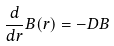Convert formula to latex. <formula><loc_0><loc_0><loc_500><loc_500>\frac { d } { d r } B ( r ) = - D B</formula> 